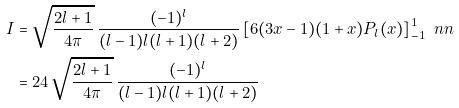<formula> <loc_0><loc_0><loc_500><loc_500>I & = \sqrt { \frac { 2 l + 1 } { 4 \pi } } \, \frac { ( - 1 ) ^ { l } } { ( l - 1 ) l ( l + 1 ) ( l + 2 ) } \left [ 6 ( 3 x - 1 ) ( 1 + x ) P _ { l } ( x ) \right ] _ { - 1 } ^ { 1 } \ n n \\ & = 2 4 \, \sqrt { \frac { 2 l + 1 } { 4 \pi } } \, \frac { ( - 1 ) ^ { l } } { ( l - 1 ) l ( l + 1 ) ( l + 2 ) }</formula> 